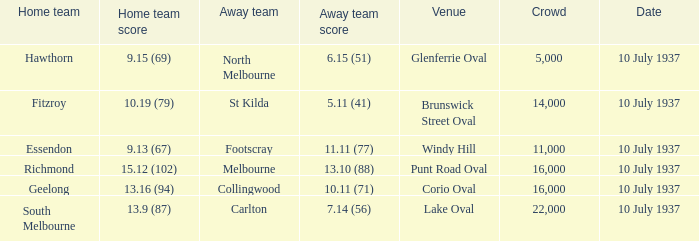What is the lowest Crowd with a Home Team Score of 9.15 (69)? 5000.0. 